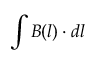<formula> <loc_0><loc_0><loc_500><loc_500>\int B ( l ) \cdot d l</formula> 